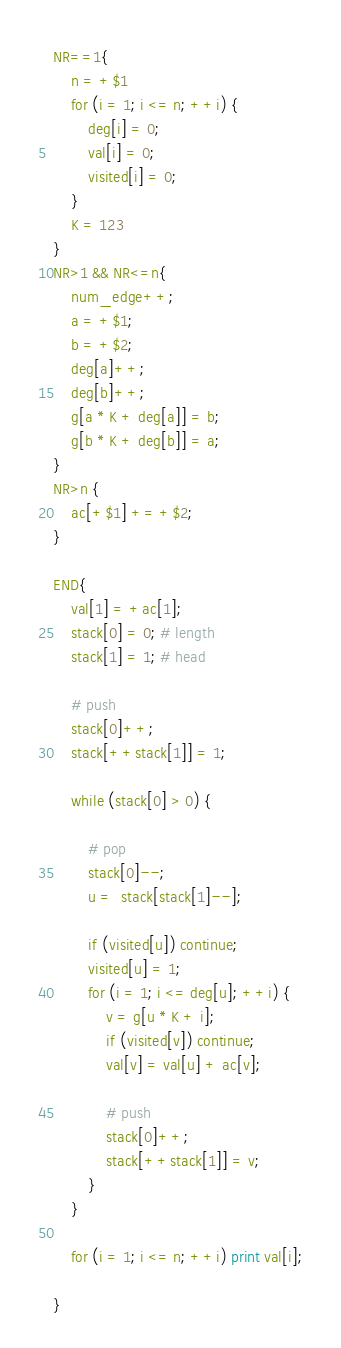Convert code to text. <code><loc_0><loc_0><loc_500><loc_500><_Awk_>NR==1{
    n = +$1
    for (i = 1; i <= n; ++i) {
        deg[i] = 0;
        val[i] = 0;
        visited[i] = 0;
    }
    K = 123
}
NR>1 && NR<=n{
    num_edge++;
    a = +$1;
    b = +$2;
    deg[a]++;
    deg[b]++;
    g[a * K + deg[a]] = b;
    g[b * K + deg[b]] = a;
}
NR>n {
    ac[+$1] += +$2;
}

END{
    val[1] = +ac[1];
    stack[0] = 0; # length
    stack[1] = 1; # head

    # push
    stack[0]++;
    stack[++stack[1]] = 1;

    while (stack[0] > 0) {

        # pop
        stack[0]--;
        u =  stack[stack[1]--];

        if (visited[u]) continue;
        visited[u] = 1;
        for (i = 1; i <= deg[u]; ++i) {
            v = g[u * K + i];
            if (visited[v]) continue;
            val[v] = val[u] + ac[v];

            # push
            stack[0]++;
            stack[++stack[1]] = v;
        }
    }

    for (i = 1; i <= n; ++i) print val[i];

}
</code> 